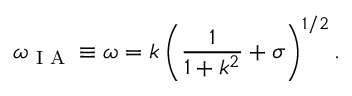<formula> <loc_0><loc_0><loc_500><loc_500>\omega _ { I A } \equiv \omega = k \left ( \frac { 1 } { 1 + k ^ { 2 } } + \sigma \right ) ^ { 1 / 2 } .</formula> 